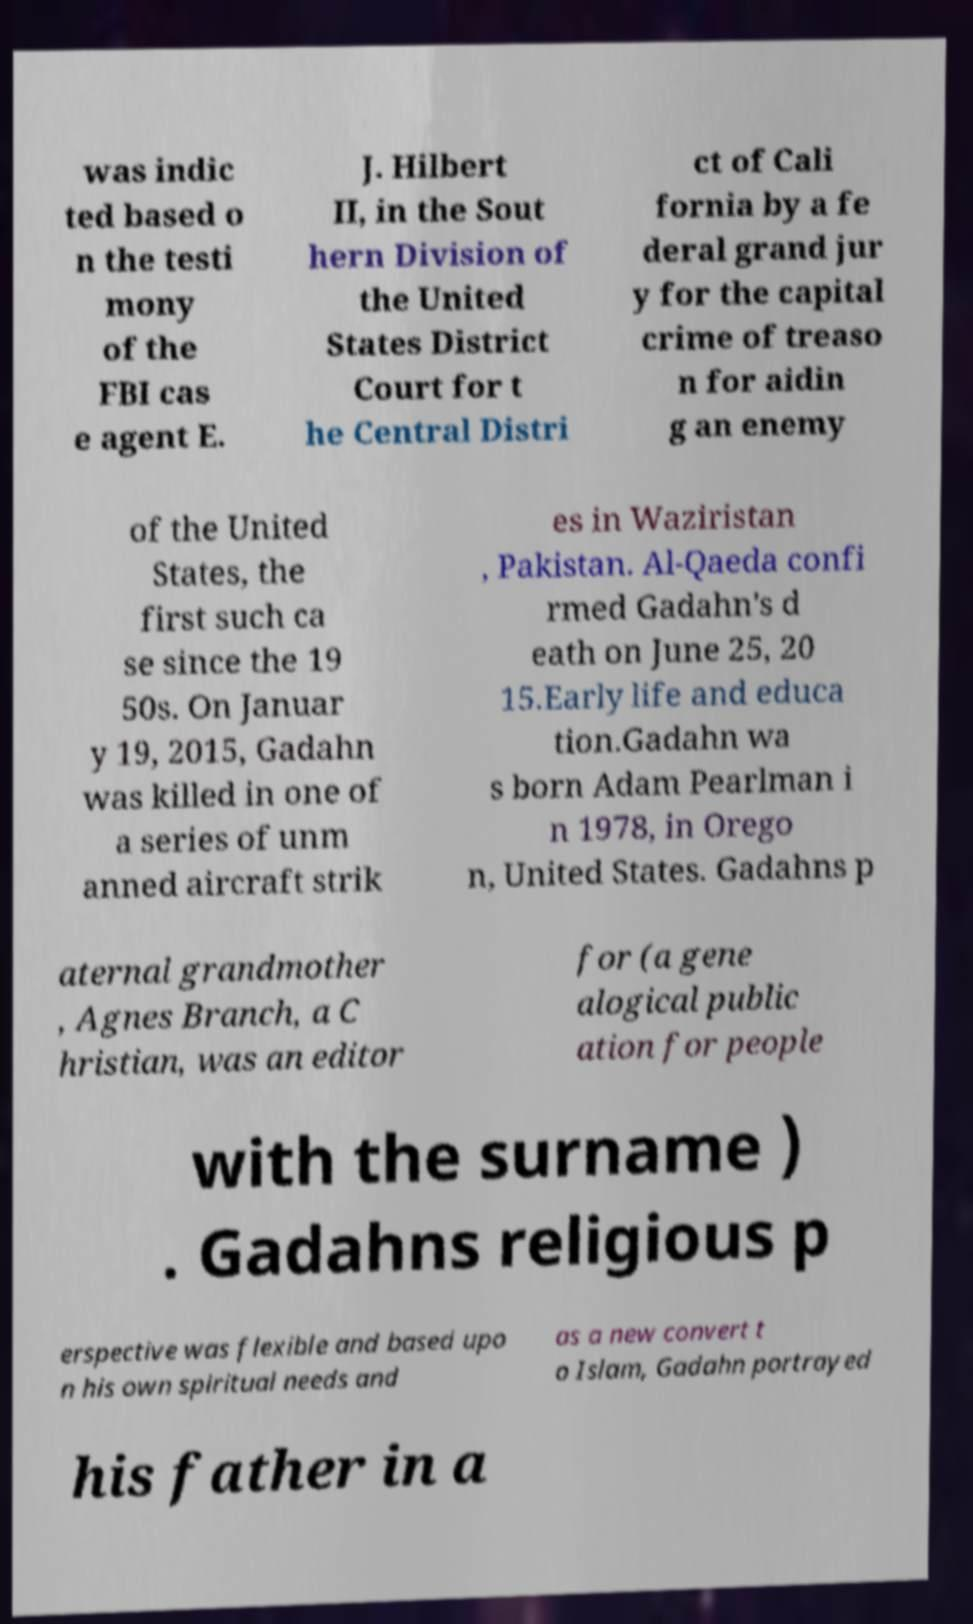Could you extract and type out the text from this image? was indic ted based o n the testi mony of the FBI cas e agent E. J. Hilbert II, in the Sout hern Division of the United States District Court for t he Central Distri ct of Cali fornia by a fe deral grand jur y for the capital crime of treaso n for aidin g an enemy of the United States, the first such ca se since the 19 50s. On Januar y 19, 2015, Gadahn was killed in one of a series of unm anned aircraft strik es in Waziristan , Pakistan. Al-Qaeda confi rmed Gadahn's d eath on June 25, 20 15.Early life and educa tion.Gadahn wa s born Adam Pearlman i n 1978, in Orego n, United States. Gadahns p aternal grandmother , Agnes Branch, a C hristian, was an editor for (a gene alogical public ation for people with the surname ) . Gadahns religious p erspective was flexible and based upo n his own spiritual needs and as a new convert t o Islam, Gadahn portrayed his father in a 